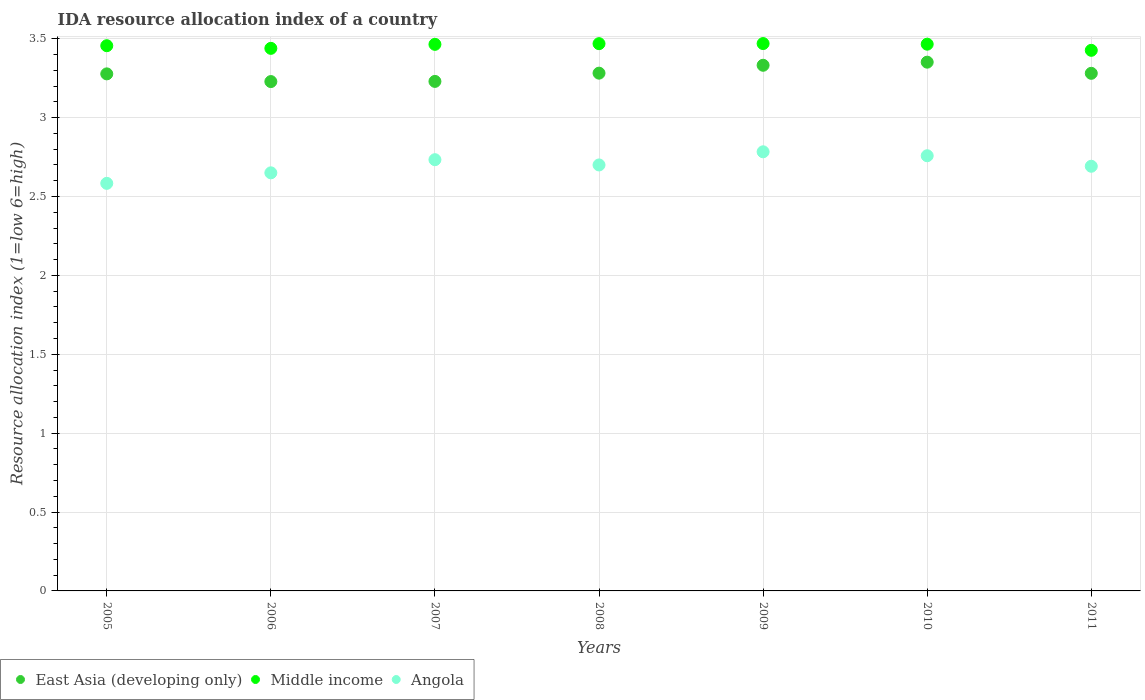Is the number of dotlines equal to the number of legend labels?
Provide a short and direct response. Yes. What is the IDA resource allocation index in Middle income in 2008?
Provide a short and direct response. 3.47. Across all years, what is the maximum IDA resource allocation index in East Asia (developing only)?
Make the answer very short. 3.35. Across all years, what is the minimum IDA resource allocation index in Angola?
Your answer should be compact. 2.58. In which year was the IDA resource allocation index in Angola minimum?
Your answer should be compact. 2005. What is the total IDA resource allocation index in Angola in the graph?
Give a very brief answer. 18.9. What is the difference between the IDA resource allocation index in Middle income in 2006 and that in 2007?
Give a very brief answer. -0.03. What is the difference between the IDA resource allocation index in Angola in 2010 and the IDA resource allocation index in Middle income in 2009?
Offer a very short reply. -0.71. What is the average IDA resource allocation index in Middle income per year?
Provide a succinct answer. 3.46. In the year 2010, what is the difference between the IDA resource allocation index in Middle income and IDA resource allocation index in East Asia (developing only)?
Your response must be concise. 0.11. What is the ratio of the IDA resource allocation index in East Asia (developing only) in 2007 to that in 2010?
Your answer should be very brief. 0.96. Is the difference between the IDA resource allocation index in Middle income in 2009 and 2011 greater than the difference between the IDA resource allocation index in East Asia (developing only) in 2009 and 2011?
Offer a terse response. No. What is the difference between the highest and the second highest IDA resource allocation index in Middle income?
Provide a short and direct response. 0. What is the difference between the highest and the lowest IDA resource allocation index in Angola?
Provide a short and direct response. 0.2. Is the sum of the IDA resource allocation index in East Asia (developing only) in 2008 and 2010 greater than the maximum IDA resource allocation index in Middle income across all years?
Your answer should be compact. Yes. Is it the case that in every year, the sum of the IDA resource allocation index in Angola and IDA resource allocation index in Middle income  is greater than the IDA resource allocation index in East Asia (developing only)?
Make the answer very short. Yes. Is the IDA resource allocation index in Angola strictly less than the IDA resource allocation index in East Asia (developing only) over the years?
Offer a terse response. Yes. How many years are there in the graph?
Provide a short and direct response. 7. Are the values on the major ticks of Y-axis written in scientific E-notation?
Provide a succinct answer. No. Does the graph contain grids?
Ensure brevity in your answer.  Yes. What is the title of the graph?
Your answer should be very brief. IDA resource allocation index of a country. What is the label or title of the Y-axis?
Your answer should be compact. Resource allocation index (1=low 6=high). What is the Resource allocation index (1=low 6=high) in East Asia (developing only) in 2005?
Keep it short and to the point. 3.28. What is the Resource allocation index (1=low 6=high) in Middle income in 2005?
Your answer should be compact. 3.46. What is the Resource allocation index (1=low 6=high) of Angola in 2005?
Your answer should be very brief. 2.58. What is the Resource allocation index (1=low 6=high) in East Asia (developing only) in 2006?
Offer a terse response. 3.23. What is the Resource allocation index (1=low 6=high) in Middle income in 2006?
Offer a terse response. 3.44. What is the Resource allocation index (1=low 6=high) in Angola in 2006?
Offer a very short reply. 2.65. What is the Resource allocation index (1=low 6=high) of East Asia (developing only) in 2007?
Offer a terse response. 3.23. What is the Resource allocation index (1=low 6=high) of Middle income in 2007?
Ensure brevity in your answer.  3.46. What is the Resource allocation index (1=low 6=high) of Angola in 2007?
Offer a terse response. 2.73. What is the Resource allocation index (1=low 6=high) of East Asia (developing only) in 2008?
Your response must be concise. 3.28. What is the Resource allocation index (1=low 6=high) of Middle income in 2008?
Give a very brief answer. 3.47. What is the Resource allocation index (1=low 6=high) of East Asia (developing only) in 2009?
Your answer should be compact. 3.33. What is the Resource allocation index (1=low 6=high) of Middle income in 2009?
Your answer should be compact. 3.47. What is the Resource allocation index (1=low 6=high) in Angola in 2009?
Your answer should be compact. 2.78. What is the Resource allocation index (1=low 6=high) of East Asia (developing only) in 2010?
Offer a very short reply. 3.35. What is the Resource allocation index (1=low 6=high) of Middle income in 2010?
Offer a terse response. 3.47. What is the Resource allocation index (1=low 6=high) of Angola in 2010?
Provide a succinct answer. 2.76. What is the Resource allocation index (1=low 6=high) in East Asia (developing only) in 2011?
Your response must be concise. 3.28. What is the Resource allocation index (1=low 6=high) in Middle income in 2011?
Provide a short and direct response. 3.43. What is the Resource allocation index (1=low 6=high) of Angola in 2011?
Provide a short and direct response. 2.69. Across all years, what is the maximum Resource allocation index (1=low 6=high) of East Asia (developing only)?
Offer a terse response. 3.35. Across all years, what is the maximum Resource allocation index (1=low 6=high) in Middle income?
Give a very brief answer. 3.47. Across all years, what is the maximum Resource allocation index (1=low 6=high) in Angola?
Provide a succinct answer. 2.78. Across all years, what is the minimum Resource allocation index (1=low 6=high) in East Asia (developing only)?
Your answer should be very brief. 3.23. Across all years, what is the minimum Resource allocation index (1=low 6=high) of Middle income?
Keep it short and to the point. 3.43. Across all years, what is the minimum Resource allocation index (1=low 6=high) in Angola?
Your answer should be very brief. 2.58. What is the total Resource allocation index (1=low 6=high) in East Asia (developing only) in the graph?
Offer a terse response. 22.98. What is the total Resource allocation index (1=low 6=high) of Middle income in the graph?
Your response must be concise. 24.19. What is the difference between the Resource allocation index (1=low 6=high) of East Asia (developing only) in 2005 and that in 2006?
Ensure brevity in your answer.  0.05. What is the difference between the Resource allocation index (1=low 6=high) of Middle income in 2005 and that in 2006?
Ensure brevity in your answer.  0.02. What is the difference between the Resource allocation index (1=low 6=high) in Angola in 2005 and that in 2006?
Your response must be concise. -0.07. What is the difference between the Resource allocation index (1=low 6=high) in East Asia (developing only) in 2005 and that in 2007?
Offer a very short reply. 0.05. What is the difference between the Resource allocation index (1=low 6=high) in Middle income in 2005 and that in 2007?
Your answer should be compact. -0.01. What is the difference between the Resource allocation index (1=low 6=high) of East Asia (developing only) in 2005 and that in 2008?
Your answer should be very brief. -0. What is the difference between the Resource allocation index (1=low 6=high) in Middle income in 2005 and that in 2008?
Ensure brevity in your answer.  -0.01. What is the difference between the Resource allocation index (1=low 6=high) of Angola in 2005 and that in 2008?
Keep it short and to the point. -0.12. What is the difference between the Resource allocation index (1=low 6=high) in East Asia (developing only) in 2005 and that in 2009?
Keep it short and to the point. -0.05. What is the difference between the Resource allocation index (1=low 6=high) of Middle income in 2005 and that in 2009?
Provide a short and direct response. -0.01. What is the difference between the Resource allocation index (1=low 6=high) in Angola in 2005 and that in 2009?
Keep it short and to the point. -0.2. What is the difference between the Resource allocation index (1=low 6=high) of East Asia (developing only) in 2005 and that in 2010?
Provide a succinct answer. -0.07. What is the difference between the Resource allocation index (1=low 6=high) in Middle income in 2005 and that in 2010?
Give a very brief answer. -0.01. What is the difference between the Resource allocation index (1=low 6=high) in Angola in 2005 and that in 2010?
Your answer should be compact. -0.17. What is the difference between the Resource allocation index (1=low 6=high) in East Asia (developing only) in 2005 and that in 2011?
Give a very brief answer. -0. What is the difference between the Resource allocation index (1=low 6=high) of Middle income in 2005 and that in 2011?
Give a very brief answer. 0.03. What is the difference between the Resource allocation index (1=low 6=high) of Angola in 2005 and that in 2011?
Keep it short and to the point. -0.11. What is the difference between the Resource allocation index (1=low 6=high) of East Asia (developing only) in 2006 and that in 2007?
Offer a very short reply. -0. What is the difference between the Resource allocation index (1=low 6=high) in Middle income in 2006 and that in 2007?
Your answer should be very brief. -0.03. What is the difference between the Resource allocation index (1=low 6=high) in Angola in 2006 and that in 2007?
Offer a terse response. -0.08. What is the difference between the Resource allocation index (1=low 6=high) in East Asia (developing only) in 2006 and that in 2008?
Your response must be concise. -0.05. What is the difference between the Resource allocation index (1=low 6=high) of Middle income in 2006 and that in 2008?
Offer a very short reply. -0.03. What is the difference between the Resource allocation index (1=low 6=high) of Angola in 2006 and that in 2008?
Provide a succinct answer. -0.05. What is the difference between the Resource allocation index (1=low 6=high) of East Asia (developing only) in 2006 and that in 2009?
Ensure brevity in your answer.  -0.1. What is the difference between the Resource allocation index (1=low 6=high) of Middle income in 2006 and that in 2009?
Offer a very short reply. -0.03. What is the difference between the Resource allocation index (1=low 6=high) in Angola in 2006 and that in 2009?
Provide a short and direct response. -0.13. What is the difference between the Resource allocation index (1=low 6=high) in East Asia (developing only) in 2006 and that in 2010?
Make the answer very short. -0.12. What is the difference between the Resource allocation index (1=low 6=high) in Middle income in 2006 and that in 2010?
Make the answer very short. -0.03. What is the difference between the Resource allocation index (1=low 6=high) of Angola in 2006 and that in 2010?
Your answer should be very brief. -0.11. What is the difference between the Resource allocation index (1=low 6=high) in East Asia (developing only) in 2006 and that in 2011?
Offer a very short reply. -0.05. What is the difference between the Resource allocation index (1=low 6=high) in Middle income in 2006 and that in 2011?
Your answer should be compact. 0.01. What is the difference between the Resource allocation index (1=low 6=high) of Angola in 2006 and that in 2011?
Your answer should be very brief. -0.04. What is the difference between the Resource allocation index (1=low 6=high) of East Asia (developing only) in 2007 and that in 2008?
Provide a short and direct response. -0.05. What is the difference between the Resource allocation index (1=low 6=high) in Middle income in 2007 and that in 2008?
Make the answer very short. -0. What is the difference between the Resource allocation index (1=low 6=high) in East Asia (developing only) in 2007 and that in 2009?
Ensure brevity in your answer.  -0.1. What is the difference between the Resource allocation index (1=low 6=high) of Middle income in 2007 and that in 2009?
Your answer should be very brief. -0.01. What is the difference between the Resource allocation index (1=low 6=high) in East Asia (developing only) in 2007 and that in 2010?
Offer a very short reply. -0.12. What is the difference between the Resource allocation index (1=low 6=high) in Middle income in 2007 and that in 2010?
Offer a terse response. -0. What is the difference between the Resource allocation index (1=low 6=high) of Angola in 2007 and that in 2010?
Provide a short and direct response. -0.03. What is the difference between the Resource allocation index (1=low 6=high) of East Asia (developing only) in 2007 and that in 2011?
Provide a succinct answer. -0.05. What is the difference between the Resource allocation index (1=low 6=high) in Middle income in 2007 and that in 2011?
Make the answer very short. 0.04. What is the difference between the Resource allocation index (1=low 6=high) in Angola in 2007 and that in 2011?
Your response must be concise. 0.04. What is the difference between the Resource allocation index (1=low 6=high) of Middle income in 2008 and that in 2009?
Give a very brief answer. -0. What is the difference between the Resource allocation index (1=low 6=high) of Angola in 2008 and that in 2009?
Your response must be concise. -0.08. What is the difference between the Resource allocation index (1=low 6=high) of East Asia (developing only) in 2008 and that in 2010?
Offer a terse response. -0.07. What is the difference between the Resource allocation index (1=low 6=high) in Middle income in 2008 and that in 2010?
Give a very brief answer. 0. What is the difference between the Resource allocation index (1=low 6=high) in Angola in 2008 and that in 2010?
Provide a succinct answer. -0.06. What is the difference between the Resource allocation index (1=low 6=high) in East Asia (developing only) in 2008 and that in 2011?
Keep it short and to the point. 0. What is the difference between the Resource allocation index (1=low 6=high) of Middle income in 2008 and that in 2011?
Your answer should be very brief. 0.04. What is the difference between the Resource allocation index (1=low 6=high) of Angola in 2008 and that in 2011?
Keep it short and to the point. 0.01. What is the difference between the Resource allocation index (1=low 6=high) of East Asia (developing only) in 2009 and that in 2010?
Your answer should be compact. -0.02. What is the difference between the Resource allocation index (1=low 6=high) in Middle income in 2009 and that in 2010?
Keep it short and to the point. 0. What is the difference between the Resource allocation index (1=low 6=high) in Angola in 2009 and that in 2010?
Provide a succinct answer. 0.03. What is the difference between the Resource allocation index (1=low 6=high) of East Asia (developing only) in 2009 and that in 2011?
Offer a very short reply. 0.05. What is the difference between the Resource allocation index (1=low 6=high) of Middle income in 2009 and that in 2011?
Provide a short and direct response. 0.04. What is the difference between the Resource allocation index (1=low 6=high) in Angola in 2009 and that in 2011?
Offer a terse response. 0.09. What is the difference between the Resource allocation index (1=low 6=high) in East Asia (developing only) in 2010 and that in 2011?
Keep it short and to the point. 0.07. What is the difference between the Resource allocation index (1=low 6=high) in Middle income in 2010 and that in 2011?
Provide a short and direct response. 0.04. What is the difference between the Resource allocation index (1=low 6=high) in Angola in 2010 and that in 2011?
Make the answer very short. 0.07. What is the difference between the Resource allocation index (1=low 6=high) in East Asia (developing only) in 2005 and the Resource allocation index (1=low 6=high) in Middle income in 2006?
Your answer should be very brief. -0.16. What is the difference between the Resource allocation index (1=low 6=high) of East Asia (developing only) in 2005 and the Resource allocation index (1=low 6=high) of Angola in 2006?
Provide a succinct answer. 0.63. What is the difference between the Resource allocation index (1=low 6=high) of Middle income in 2005 and the Resource allocation index (1=low 6=high) of Angola in 2006?
Provide a succinct answer. 0.81. What is the difference between the Resource allocation index (1=low 6=high) of East Asia (developing only) in 2005 and the Resource allocation index (1=low 6=high) of Middle income in 2007?
Ensure brevity in your answer.  -0.19. What is the difference between the Resource allocation index (1=low 6=high) of East Asia (developing only) in 2005 and the Resource allocation index (1=low 6=high) of Angola in 2007?
Ensure brevity in your answer.  0.54. What is the difference between the Resource allocation index (1=low 6=high) of Middle income in 2005 and the Resource allocation index (1=low 6=high) of Angola in 2007?
Your answer should be very brief. 0.72. What is the difference between the Resource allocation index (1=low 6=high) in East Asia (developing only) in 2005 and the Resource allocation index (1=low 6=high) in Middle income in 2008?
Provide a succinct answer. -0.19. What is the difference between the Resource allocation index (1=low 6=high) in East Asia (developing only) in 2005 and the Resource allocation index (1=low 6=high) in Angola in 2008?
Your answer should be compact. 0.58. What is the difference between the Resource allocation index (1=low 6=high) in Middle income in 2005 and the Resource allocation index (1=low 6=high) in Angola in 2008?
Give a very brief answer. 0.76. What is the difference between the Resource allocation index (1=low 6=high) in East Asia (developing only) in 2005 and the Resource allocation index (1=low 6=high) in Middle income in 2009?
Give a very brief answer. -0.19. What is the difference between the Resource allocation index (1=low 6=high) of East Asia (developing only) in 2005 and the Resource allocation index (1=low 6=high) of Angola in 2009?
Your response must be concise. 0.49. What is the difference between the Resource allocation index (1=low 6=high) in Middle income in 2005 and the Resource allocation index (1=low 6=high) in Angola in 2009?
Provide a succinct answer. 0.67. What is the difference between the Resource allocation index (1=low 6=high) in East Asia (developing only) in 2005 and the Resource allocation index (1=low 6=high) in Middle income in 2010?
Make the answer very short. -0.19. What is the difference between the Resource allocation index (1=low 6=high) of East Asia (developing only) in 2005 and the Resource allocation index (1=low 6=high) of Angola in 2010?
Provide a short and direct response. 0.52. What is the difference between the Resource allocation index (1=low 6=high) in Middle income in 2005 and the Resource allocation index (1=low 6=high) in Angola in 2010?
Provide a succinct answer. 0.7. What is the difference between the Resource allocation index (1=low 6=high) in East Asia (developing only) in 2005 and the Resource allocation index (1=low 6=high) in Middle income in 2011?
Ensure brevity in your answer.  -0.15. What is the difference between the Resource allocation index (1=low 6=high) in East Asia (developing only) in 2005 and the Resource allocation index (1=low 6=high) in Angola in 2011?
Keep it short and to the point. 0.59. What is the difference between the Resource allocation index (1=low 6=high) in Middle income in 2005 and the Resource allocation index (1=low 6=high) in Angola in 2011?
Your answer should be compact. 0.76. What is the difference between the Resource allocation index (1=low 6=high) in East Asia (developing only) in 2006 and the Resource allocation index (1=low 6=high) in Middle income in 2007?
Provide a short and direct response. -0.24. What is the difference between the Resource allocation index (1=low 6=high) of East Asia (developing only) in 2006 and the Resource allocation index (1=low 6=high) of Angola in 2007?
Ensure brevity in your answer.  0.5. What is the difference between the Resource allocation index (1=low 6=high) in Middle income in 2006 and the Resource allocation index (1=low 6=high) in Angola in 2007?
Ensure brevity in your answer.  0.71. What is the difference between the Resource allocation index (1=low 6=high) of East Asia (developing only) in 2006 and the Resource allocation index (1=low 6=high) of Middle income in 2008?
Provide a short and direct response. -0.24. What is the difference between the Resource allocation index (1=low 6=high) of East Asia (developing only) in 2006 and the Resource allocation index (1=low 6=high) of Angola in 2008?
Make the answer very short. 0.53. What is the difference between the Resource allocation index (1=low 6=high) in Middle income in 2006 and the Resource allocation index (1=low 6=high) in Angola in 2008?
Provide a succinct answer. 0.74. What is the difference between the Resource allocation index (1=low 6=high) in East Asia (developing only) in 2006 and the Resource allocation index (1=low 6=high) in Middle income in 2009?
Ensure brevity in your answer.  -0.24. What is the difference between the Resource allocation index (1=low 6=high) of East Asia (developing only) in 2006 and the Resource allocation index (1=low 6=high) of Angola in 2009?
Provide a succinct answer. 0.45. What is the difference between the Resource allocation index (1=low 6=high) of Middle income in 2006 and the Resource allocation index (1=low 6=high) of Angola in 2009?
Offer a terse response. 0.66. What is the difference between the Resource allocation index (1=low 6=high) of East Asia (developing only) in 2006 and the Resource allocation index (1=low 6=high) of Middle income in 2010?
Provide a succinct answer. -0.24. What is the difference between the Resource allocation index (1=low 6=high) of East Asia (developing only) in 2006 and the Resource allocation index (1=low 6=high) of Angola in 2010?
Make the answer very short. 0.47. What is the difference between the Resource allocation index (1=low 6=high) of Middle income in 2006 and the Resource allocation index (1=low 6=high) of Angola in 2010?
Give a very brief answer. 0.68. What is the difference between the Resource allocation index (1=low 6=high) in East Asia (developing only) in 2006 and the Resource allocation index (1=low 6=high) in Middle income in 2011?
Your answer should be compact. -0.2. What is the difference between the Resource allocation index (1=low 6=high) in East Asia (developing only) in 2006 and the Resource allocation index (1=low 6=high) in Angola in 2011?
Offer a very short reply. 0.54. What is the difference between the Resource allocation index (1=low 6=high) in Middle income in 2006 and the Resource allocation index (1=low 6=high) in Angola in 2011?
Make the answer very short. 0.75. What is the difference between the Resource allocation index (1=low 6=high) of East Asia (developing only) in 2007 and the Resource allocation index (1=low 6=high) of Middle income in 2008?
Make the answer very short. -0.24. What is the difference between the Resource allocation index (1=low 6=high) in East Asia (developing only) in 2007 and the Resource allocation index (1=low 6=high) in Angola in 2008?
Give a very brief answer. 0.53. What is the difference between the Resource allocation index (1=low 6=high) of Middle income in 2007 and the Resource allocation index (1=low 6=high) of Angola in 2008?
Your response must be concise. 0.76. What is the difference between the Resource allocation index (1=low 6=high) of East Asia (developing only) in 2007 and the Resource allocation index (1=low 6=high) of Middle income in 2009?
Make the answer very short. -0.24. What is the difference between the Resource allocation index (1=low 6=high) in East Asia (developing only) in 2007 and the Resource allocation index (1=low 6=high) in Angola in 2009?
Offer a very short reply. 0.45. What is the difference between the Resource allocation index (1=low 6=high) of Middle income in 2007 and the Resource allocation index (1=low 6=high) of Angola in 2009?
Your answer should be compact. 0.68. What is the difference between the Resource allocation index (1=low 6=high) in East Asia (developing only) in 2007 and the Resource allocation index (1=low 6=high) in Middle income in 2010?
Your answer should be compact. -0.24. What is the difference between the Resource allocation index (1=low 6=high) in East Asia (developing only) in 2007 and the Resource allocation index (1=low 6=high) in Angola in 2010?
Offer a terse response. 0.47. What is the difference between the Resource allocation index (1=low 6=high) of Middle income in 2007 and the Resource allocation index (1=low 6=high) of Angola in 2010?
Your response must be concise. 0.71. What is the difference between the Resource allocation index (1=low 6=high) in East Asia (developing only) in 2007 and the Resource allocation index (1=low 6=high) in Middle income in 2011?
Your answer should be compact. -0.2. What is the difference between the Resource allocation index (1=low 6=high) in East Asia (developing only) in 2007 and the Resource allocation index (1=low 6=high) in Angola in 2011?
Offer a terse response. 0.54. What is the difference between the Resource allocation index (1=low 6=high) in Middle income in 2007 and the Resource allocation index (1=low 6=high) in Angola in 2011?
Make the answer very short. 0.77. What is the difference between the Resource allocation index (1=low 6=high) of East Asia (developing only) in 2008 and the Resource allocation index (1=low 6=high) of Middle income in 2009?
Your response must be concise. -0.19. What is the difference between the Resource allocation index (1=low 6=high) of East Asia (developing only) in 2008 and the Resource allocation index (1=low 6=high) of Angola in 2009?
Your answer should be very brief. 0.5. What is the difference between the Resource allocation index (1=low 6=high) in Middle income in 2008 and the Resource allocation index (1=low 6=high) in Angola in 2009?
Your answer should be compact. 0.69. What is the difference between the Resource allocation index (1=low 6=high) of East Asia (developing only) in 2008 and the Resource allocation index (1=low 6=high) of Middle income in 2010?
Provide a succinct answer. -0.18. What is the difference between the Resource allocation index (1=low 6=high) in East Asia (developing only) in 2008 and the Resource allocation index (1=low 6=high) in Angola in 2010?
Provide a succinct answer. 0.52. What is the difference between the Resource allocation index (1=low 6=high) in Middle income in 2008 and the Resource allocation index (1=low 6=high) in Angola in 2010?
Ensure brevity in your answer.  0.71. What is the difference between the Resource allocation index (1=low 6=high) of East Asia (developing only) in 2008 and the Resource allocation index (1=low 6=high) of Middle income in 2011?
Your answer should be very brief. -0.14. What is the difference between the Resource allocation index (1=low 6=high) in East Asia (developing only) in 2008 and the Resource allocation index (1=low 6=high) in Angola in 2011?
Keep it short and to the point. 0.59. What is the difference between the Resource allocation index (1=low 6=high) of Middle income in 2008 and the Resource allocation index (1=low 6=high) of Angola in 2011?
Provide a short and direct response. 0.78. What is the difference between the Resource allocation index (1=low 6=high) of East Asia (developing only) in 2009 and the Resource allocation index (1=low 6=high) of Middle income in 2010?
Your answer should be very brief. -0.13. What is the difference between the Resource allocation index (1=low 6=high) of East Asia (developing only) in 2009 and the Resource allocation index (1=low 6=high) of Angola in 2010?
Your response must be concise. 0.57. What is the difference between the Resource allocation index (1=low 6=high) in Middle income in 2009 and the Resource allocation index (1=low 6=high) in Angola in 2010?
Offer a terse response. 0.71. What is the difference between the Resource allocation index (1=low 6=high) in East Asia (developing only) in 2009 and the Resource allocation index (1=low 6=high) in Middle income in 2011?
Give a very brief answer. -0.09. What is the difference between the Resource allocation index (1=low 6=high) in East Asia (developing only) in 2009 and the Resource allocation index (1=low 6=high) in Angola in 2011?
Offer a terse response. 0.64. What is the difference between the Resource allocation index (1=low 6=high) of Middle income in 2009 and the Resource allocation index (1=low 6=high) of Angola in 2011?
Your answer should be very brief. 0.78. What is the difference between the Resource allocation index (1=low 6=high) in East Asia (developing only) in 2010 and the Resource allocation index (1=low 6=high) in Middle income in 2011?
Offer a terse response. -0.07. What is the difference between the Resource allocation index (1=low 6=high) in East Asia (developing only) in 2010 and the Resource allocation index (1=low 6=high) in Angola in 2011?
Make the answer very short. 0.66. What is the difference between the Resource allocation index (1=low 6=high) in Middle income in 2010 and the Resource allocation index (1=low 6=high) in Angola in 2011?
Provide a succinct answer. 0.77. What is the average Resource allocation index (1=low 6=high) of East Asia (developing only) per year?
Give a very brief answer. 3.28. What is the average Resource allocation index (1=low 6=high) in Middle income per year?
Offer a very short reply. 3.46. In the year 2005, what is the difference between the Resource allocation index (1=low 6=high) in East Asia (developing only) and Resource allocation index (1=low 6=high) in Middle income?
Ensure brevity in your answer.  -0.18. In the year 2005, what is the difference between the Resource allocation index (1=low 6=high) in East Asia (developing only) and Resource allocation index (1=low 6=high) in Angola?
Give a very brief answer. 0.69. In the year 2005, what is the difference between the Resource allocation index (1=low 6=high) of Middle income and Resource allocation index (1=low 6=high) of Angola?
Provide a succinct answer. 0.87. In the year 2006, what is the difference between the Resource allocation index (1=low 6=high) of East Asia (developing only) and Resource allocation index (1=low 6=high) of Middle income?
Your response must be concise. -0.21. In the year 2006, what is the difference between the Resource allocation index (1=low 6=high) of East Asia (developing only) and Resource allocation index (1=low 6=high) of Angola?
Offer a terse response. 0.58. In the year 2006, what is the difference between the Resource allocation index (1=low 6=high) of Middle income and Resource allocation index (1=low 6=high) of Angola?
Ensure brevity in your answer.  0.79. In the year 2007, what is the difference between the Resource allocation index (1=low 6=high) in East Asia (developing only) and Resource allocation index (1=low 6=high) in Middle income?
Provide a succinct answer. -0.23. In the year 2007, what is the difference between the Resource allocation index (1=low 6=high) in East Asia (developing only) and Resource allocation index (1=low 6=high) in Angola?
Provide a succinct answer. 0.5. In the year 2007, what is the difference between the Resource allocation index (1=low 6=high) of Middle income and Resource allocation index (1=low 6=high) of Angola?
Offer a very short reply. 0.73. In the year 2008, what is the difference between the Resource allocation index (1=low 6=high) of East Asia (developing only) and Resource allocation index (1=low 6=high) of Middle income?
Make the answer very short. -0.19. In the year 2008, what is the difference between the Resource allocation index (1=low 6=high) in East Asia (developing only) and Resource allocation index (1=low 6=high) in Angola?
Your answer should be compact. 0.58. In the year 2008, what is the difference between the Resource allocation index (1=low 6=high) of Middle income and Resource allocation index (1=low 6=high) of Angola?
Your response must be concise. 0.77. In the year 2009, what is the difference between the Resource allocation index (1=low 6=high) in East Asia (developing only) and Resource allocation index (1=low 6=high) in Middle income?
Keep it short and to the point. -0.14. In the year 2009, what is the difference between the Resource allocation index (1=low 6=high) of East Asia (developing only) and Resource allocation index (1=low 6=high) of Angola?
Your answer should be very brief. 0.55. In the year 2009, what is the difference between the Resource allocation index (1=low 6=high) of Middle income and Resource allocation index (1=low 6=high) of Angola?
Provide a short and direct response. 0.69. In the year 2010, what is the difference between the Resource allocation index (1=low 6=high) in East Asia (developing only) and Resource allocation index (1=low 6=high) in Middle income?
Provide a short and direct response. -0.11. In the year 2010, what is the difference between the Resource allocation index (1=low 6=high) of East Asia (developing only) and Resource allocation index (1=low 6=high) of Angola?
Offer a very short reply. 0.59. In the year 2010, what is the difference between the Resource allocation index (1=low 6=high) of Middle income and Resource allocation index (1=low 6=high) of Angola?
Your answer should be very brief. 0.71. In the year 2011, what is the difference between the Resource allocation index (1=low 6=high) in East Asia (developing only) and Resource allocation index (1=low 6=high) in Middle income?
Provide a succinct answer. -0.15. In the year 2011, what is the difference between the Resource allocation index (1=low 6=high) of East Asia (developing only) and Resource allocation index (1=low 6=high) of Angola?
Offer a very short reply. 0.59. In the year 2011, what is the difference between the Resource allocation index (1=low 6=high) of Middle income and Resource allocation index (1=low 6=high) of Angola?
Your response must be concise. 0.73. What is the ratio of the Resource allocation index (1=low 6=high) in East Asia (developing only) in 2005 to that in 2006?
Make the answer very short. 1.02. What is the ratio of the Resource allocation index (1=low 6=high) of Angola in 2005 to that in 2006?
Provide a succinct answer. 0.97. What is the ratio of the Resource allocation index (1=low 6=high) in East Asia (developing only) in 2005 to that in 2007?
Keep it short and to the point. 1.01. What is the ratio of the Resource allocation index (1=low 6=high) of Middle income in 2005 to that in 2007?
Offer a terse response. 1. What is the ratio of the Resource allocation index (1=low 6=high) in Angola in 2005 to that in 2007?
Give a very brief answer. 0.95. What is the ratio of the Resource allocation index (1=low 6=high) of East Asia (developing only) in 2005 to that in 2008?
Provide a short and direct response. 1. What is the ratio of the Resource allocation index (1=low 6=high) in Middle income in 2005 to that in 2008?
Provide a succinct answer. 1. What is the ratio of the Resource allocation index (1=low 6=high) of Angola in 2005 to that in 2008?
Your answer should be compact. 0.96. What is the ratio of the Resource allocation index (1=low 6=high) of East Asia (developing only) in 2005 to that in 2009?
Your response must be concise. 0.98. What is the ratio of the Resource allocation index (1=low 6=high) in Angola in 2005 to that in 2009?
Offer a terse response. 0.93. What is the ratio of the Resource allocation index (1=low 6=high) of East Asia (developing only) in 2005 to that in 2010?
Your response must be concise. 0.98. What is the ratio of the Resource allocation index (1=low 6=high) of Middle income in 2005 to that in 2010?
Ensure brevity in your answer.  1. What is the ratio of the Resource allocation index (1=low 6=high) of Angola in 2005 to that in 2010?
Keep it short and to the point. 0.94. What is the ratio of the Resource allocation index (1=low 6=high) in Middle income in 2005 to that in 2011?
Ensure brevity in your answer.  1.01. What is the ratio of the Resource allocation index (1=low 6=high) of Angola in 2005 to that in 2011?
Make the answer very short. 0.96. What is the ratio of the Resource allocation index (1=low 6=high) of East Asia (developing only) in 2006 to that in 2007?
Keep it short and to the point. 1. What is the ratio of the Resource allocation index (1=low 6=high) of Middle income in 2006 to that in 2007?
Provide a short and direct response. 0.99. What is the ratio of the Resource allocation index (1=low 6=high) in Angola in 2006 to that in 2007?
Make the answer very short. 0.97. What is the ratio of the Resource allocation index (1=low 6=high) in East Asia (developing only) in 2006 to that in 2008?
Keep it short and to the point. 0.98. What is the ratio of the Resource allocation index (1=low 6=high) of Angola in 2006 to that in 2008?
Offer a terse response. 0.98. What is the ratio of the Resource allocation index (1=low 6=high) of Middle income in 2006 to that in 2009?
Offer a terse response. 0.99. What is the ratio of the Resource allocation index (1=low 6=high) in Angola in 2006 to that in 2009?
Give a very brief answer. 0.95. What is the ratio of the Resource allocation index (1=low 6=high) of East Asia (developing only) in 2006 to that in 2010?
Your response must be concise. 0.96. What is the ratio of the Resource allocation index (1=low 6=high) in Angola in 2006 to that in 2010?
Provide a succinct answer. 0.96. What is the ratio of the Resource allocation index (1=low 6=high) of East Asia (developing only) in 2006 to that in 2011?
Offer a terse response. 0.98. What is the ratio of the Resource allocation index (1=low 6=high) of Angola in 2006 to that in 2011?
Offer a terse response. 0.98. What is the ratio of the Resource allocation index (1=low 6=high) of East Asia (developing only) in 2007 to that in 2008?
Give a very brief answer. 0.98. What is the ratio of the Resource allocation index (1=low 6=high) in Angola in 2007 to that in 2008?
Offer a terse response. 1.01. What is the ratio of the Resource allocation index (1=low 6=high) in East Asia (developing only) in 2007 to that in 2009?
Offer a very short reply. 0.97. What is the ratio of the Resource allocation index (1=low 6=high) in Angola in 2007 to that in 2009?
Offer a terse response. 0.98. What is the ratio of the Resource allocation index (1=low 6=high) in East Asia (developing only) in 2007 to that in 2010?
Your answer should be compact. 0.96. What is the ratio of the Resource allocation index (1=low 6=high) of Angola in 2007 to that in 2010?
Give a very brief answer. 0.99. What is the ratio of the Resource allocation index (1=low 6=high) of East Asia (developing only) in 2007 to that in 2011?
Make the answer very short. 0.98. What is the ratio of the Resource allocation index (1=low 6=high) in Middle income in 2007 to that in 2011?
Provide a short and direct response. 1.01. What is the ratio of the Resource allocation index (1=low 6=high) in Angola in 2007 to that in 2011?
Provide a succinct answer. 1.02. What is the ratio of the Resource allocation index (1=low 6=high) in Angola in 2008 to that in 2009?
Your answer should be very brief. 0.97. What is the ratio of the Resource allocation index (1=low 6=high) of East Asia (developing only) in 2008 to that in 2010?
Your answer should be very brief. 0.98. What is the ratio of the Resource allocation index (1=low 6=high) in Angola in 2008 to that in 2010?
Your answer should be very brief. 0.98. What is the ratio of the Resource allocation index (1=low 6=high) in Middle income in 2008 to that in 2011?
Your answer should be very brief. 1.01. What is the ratio of the Resource allocation index (1=low 6=high) in Angola in 2008 to that in 2011?
Give a very brief answer. 1. What is the ratio of the Resource allocation index (1=low 6=high) in East Asia (developing only) in 2009 to that in 2010?
Your response must be concise. 0.99. What is the ratio of the Resource allocation index (1=low 6=high) in Angola in 2009 to that in 2010?
Your answer should be compact. 1.01. What is the ratio of the Resource allocation index (1=low 6=high) in East Asia (developing only) in 2009 to that in 2011?
Your answer should be very brief. 1.02. What is the ratio of the Resource allocation index (1=low 6=high) of Middle income in 2009 to that in 2011?
Ensure brevity in your answer.  1.01. What is the ratio of the Resource allocation index (1=low 6=high) in Angola in 2009 to that in 2011?
Your response must be concise. 1.03. What is the ratio of the Resource allocation index (1=low 6=high) of East Asia (developing only) in 2010 to that in 2011?
Your answer should be compact. 1.02. What is the ratio of the Resource allocation index (1=low 6=high) of Middle income in 2010 to that in 2011?
Make the answer very short. 1.01. What is the ratio of the Resource allocation index (1=low 6=high) in Angola in 2010 to that in 2011?
Keep it short and to the point. 1.02. What is the difference between the highest and the second highest Resource allocation index (1=low 6=high) of East Asia (developing only)?
Give a very brief answer. 0.02. What is the difference between the highest and the second highest Resource allocation index (1=low 6=high) in Middle income?
Provide a short and direct response. 0. What is the difference between the highest and the second highest Resource allocation index (1=low 6=high) of Angola?
Ensure brevity in your answer.  0.03. What is the difference between the highest and the lowest Resource allocation index (1=low 6=high) of East Asia (developing only)?
Your response must be concise. 0.12. What is the difference between the highest and the lowest Resource allocation index (1=low 6=high) in Middle income?
Ensure brevity in your answer.  0.04. 